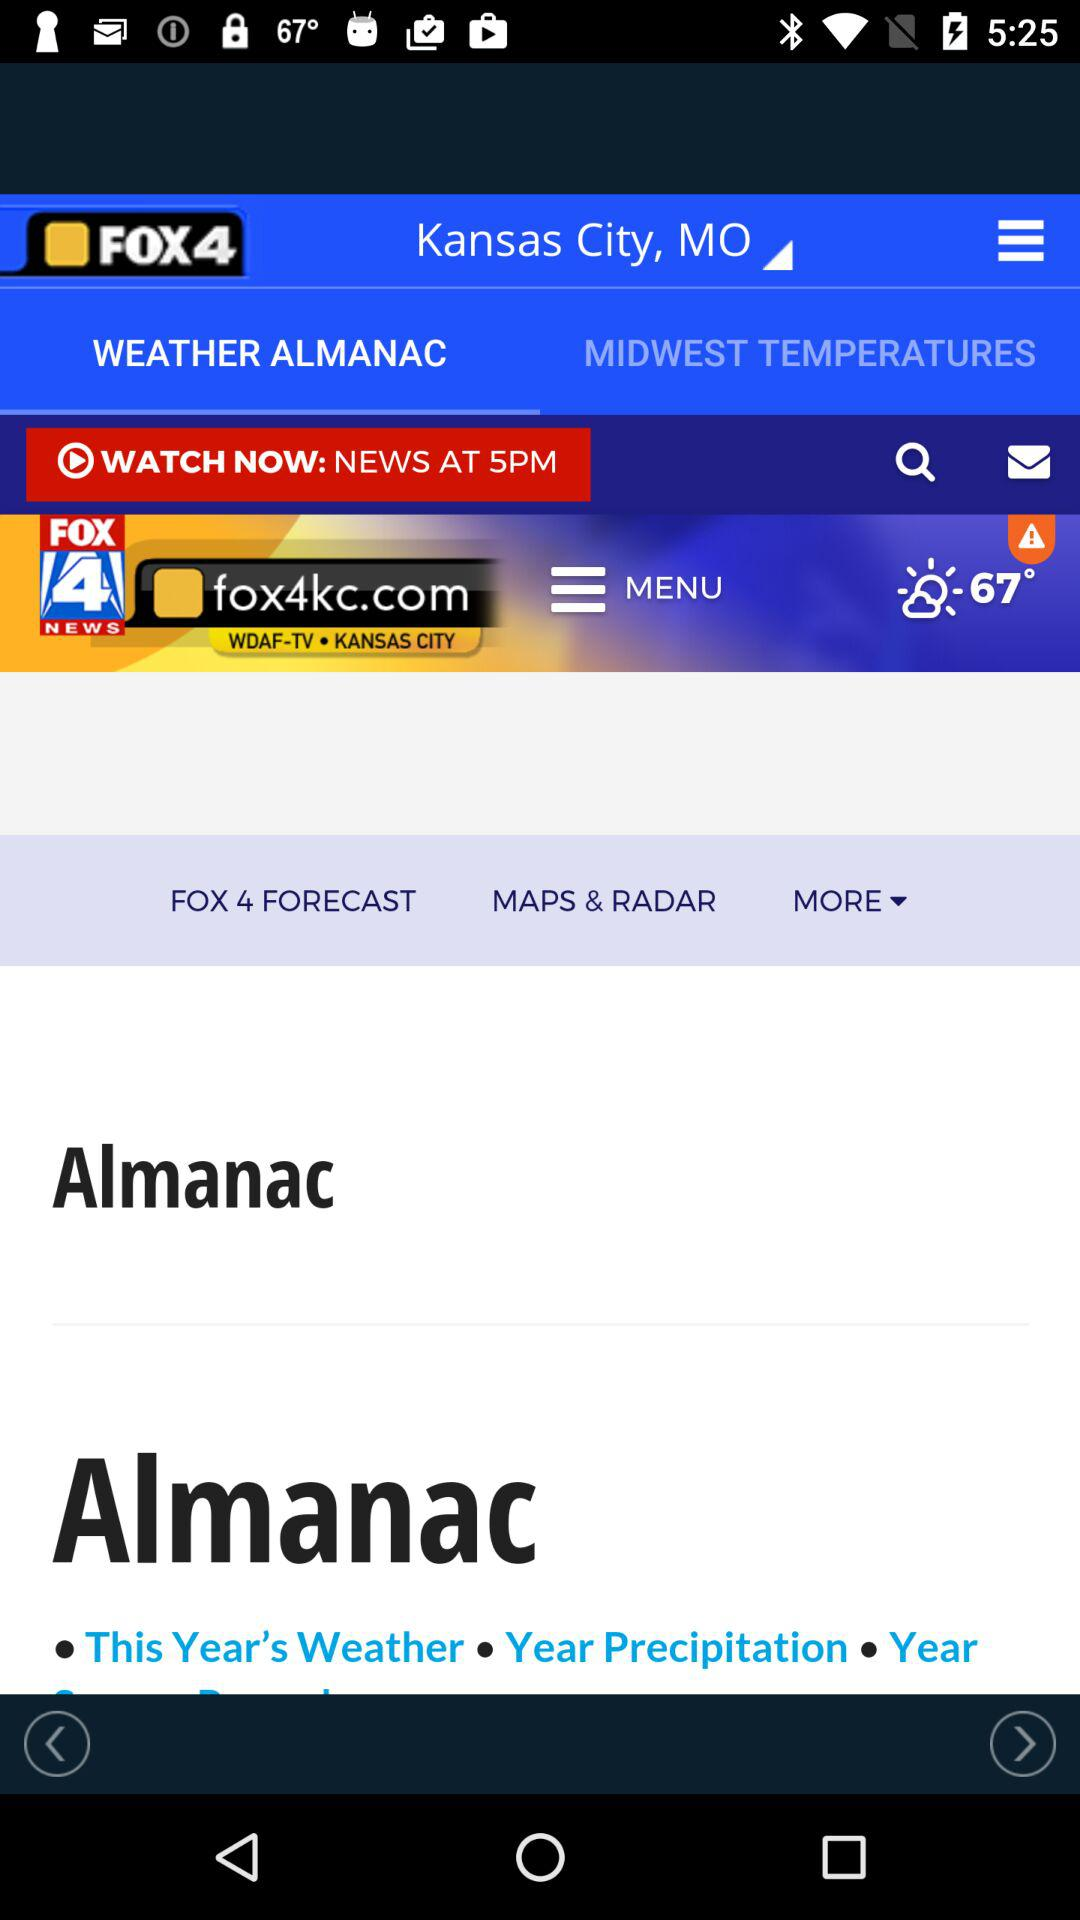What is the news channel name? The news channel name is "FOX4". 